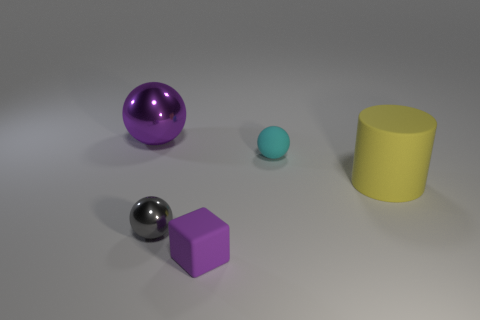Do the large cylinder and the cyan object have the same material?
Give a very brief answer. Yes. Is there anything else that has the same shape as the small metallic object?
Your response must be concise. Yes. What is the small object left of the purple thing that is to the right of the purple ball made of?
Provide a succinct answer. Metal. How big is the purple metal sphere that is behind the tiny purple thing?
Give a very brief answer. Large. There is a matte thing that is both in front of the rubber ball and on the left side of the yellow matte thing; what is its color?
Make the answer very short. Purple. There is a purple object that is to the left of the purple block; does it have the same size as the yellow thing?
Provide a short and direct response. Yes. There is a metallic object in front of the large purple shiny ball; are there any small metal spheres that are in front of it?
Keep it short and to the point. No. What is the material of the large purple object?
Your answer should be compact. Metal. There is a gray metal ball; are there any gray spheres in front of it?
Make the answer very short. No. What size is the cyan matte thing that is the same shape as the gray metallic object?
Provide a short and direct response. Small. 